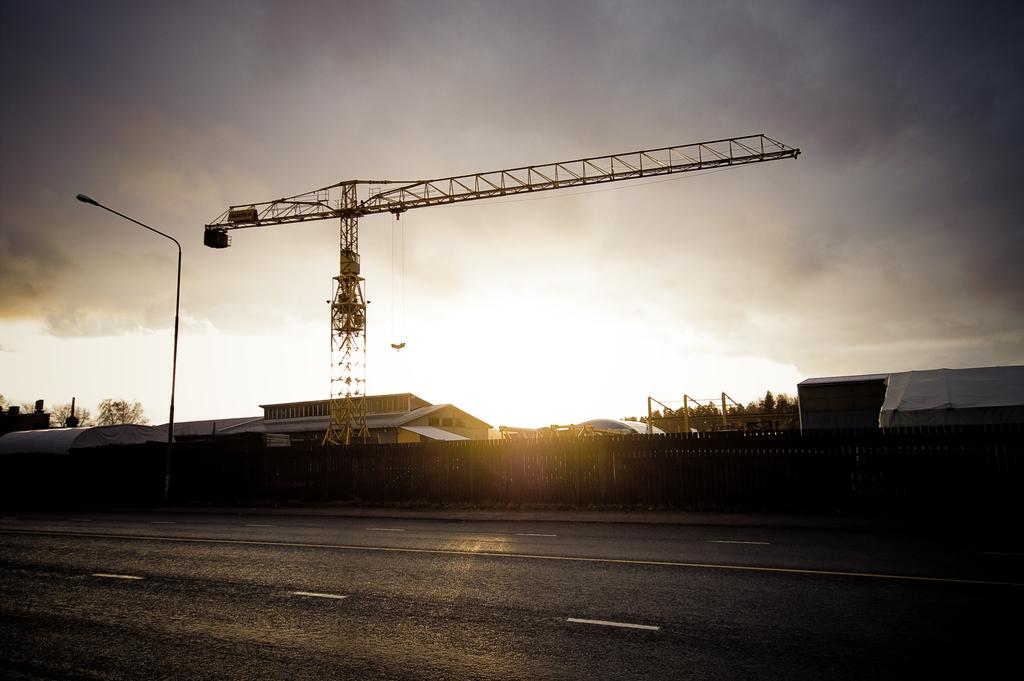What is the main feature of the image? There is a road in the image. What can be seen in the background of the image? In the background, there is a pole, fencing, sheds, a crane, and the sky. Can you describe the pole in the background? The pole is a vertical structure visible in the background of the image. What type of structures are the sheds in the background? The sheds are small, enclosed buildings in the background of the image. How many icicles are hanging from the crane in the image? There are no icicles present in the image; it is a crane in the background of the image. What are the hands of the person holding the crane doing in the image? There is no person holding the crane in the image; it is a stationary structure in the background. 